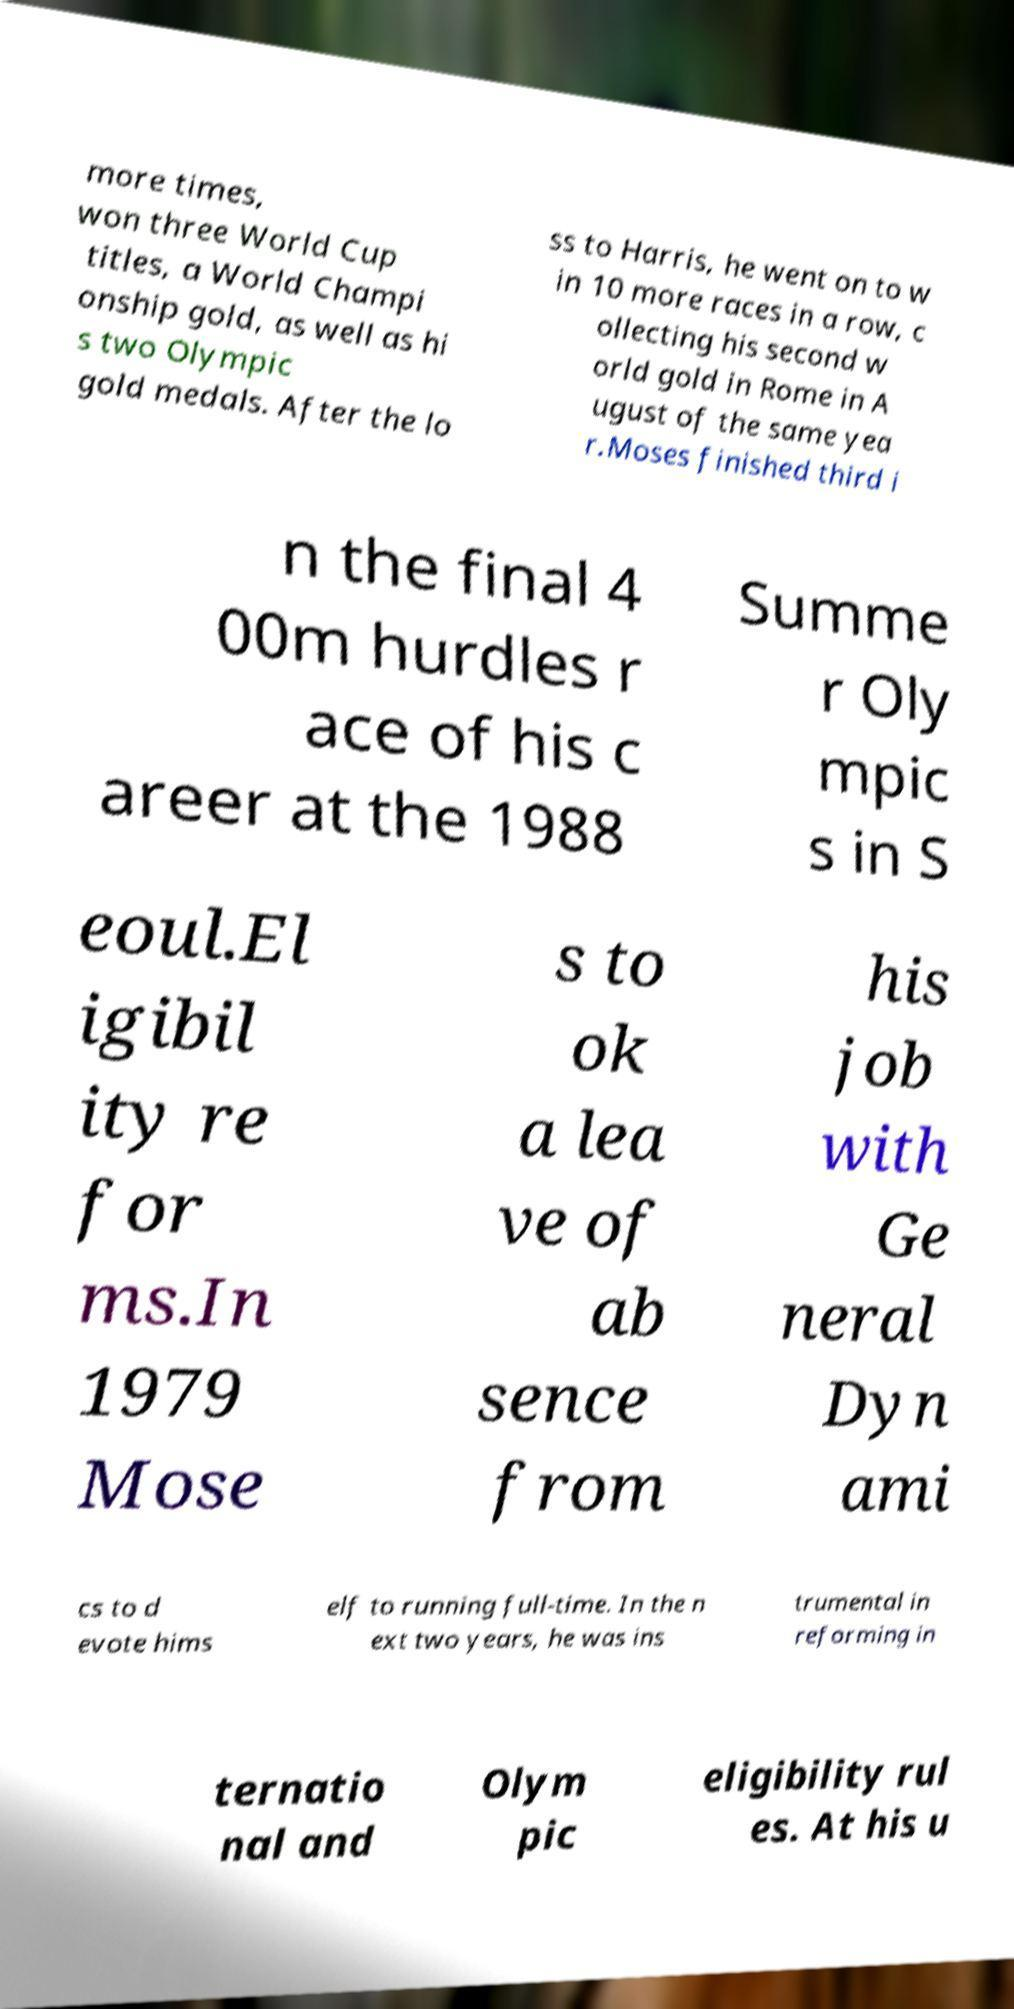There's text embedded in this image that I need extracted. Can you transcribe it verbatim? more times, won three World Cup titles, a World Champi onship gold, as well as hi s two Olympic gold medals. After the lo ss to Harris, he went on to w in 10 more races in a row, c ollecting his second w orld gold in Rome in A ugust of the same yea r.Moses finished third i n the final 4 00m hurdles r ace of his c areer at the 1988 Summe r Oly mpic s in S eoul.El igibil ity re for ms.In 1979 Mose s to ok a lea ve of ab sence from his job with Ge neral Dyn ami cs to d evote hims elf to running full-time. In the n ext two years, he was ins trumental in reforming in ternatio nal and Olym pic eligibility rul es. At his u 